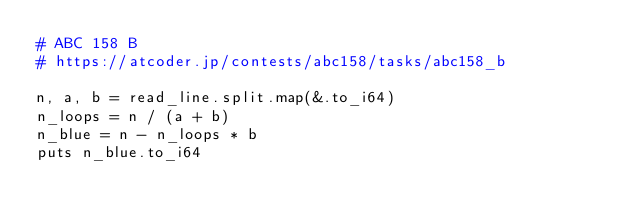<code> <loc_0><loc_0><loc_500><loc_500><_Crystal_># ABC 158 B
# https://atcoder.jp/contests/abc158/tasks/abc158_b

n, a, b = read_line.split.map(&.to_i64)
n_loops = n / (a + b)
n_blue = n - n_loops * b
puts n_blue.to_i64
</code> 